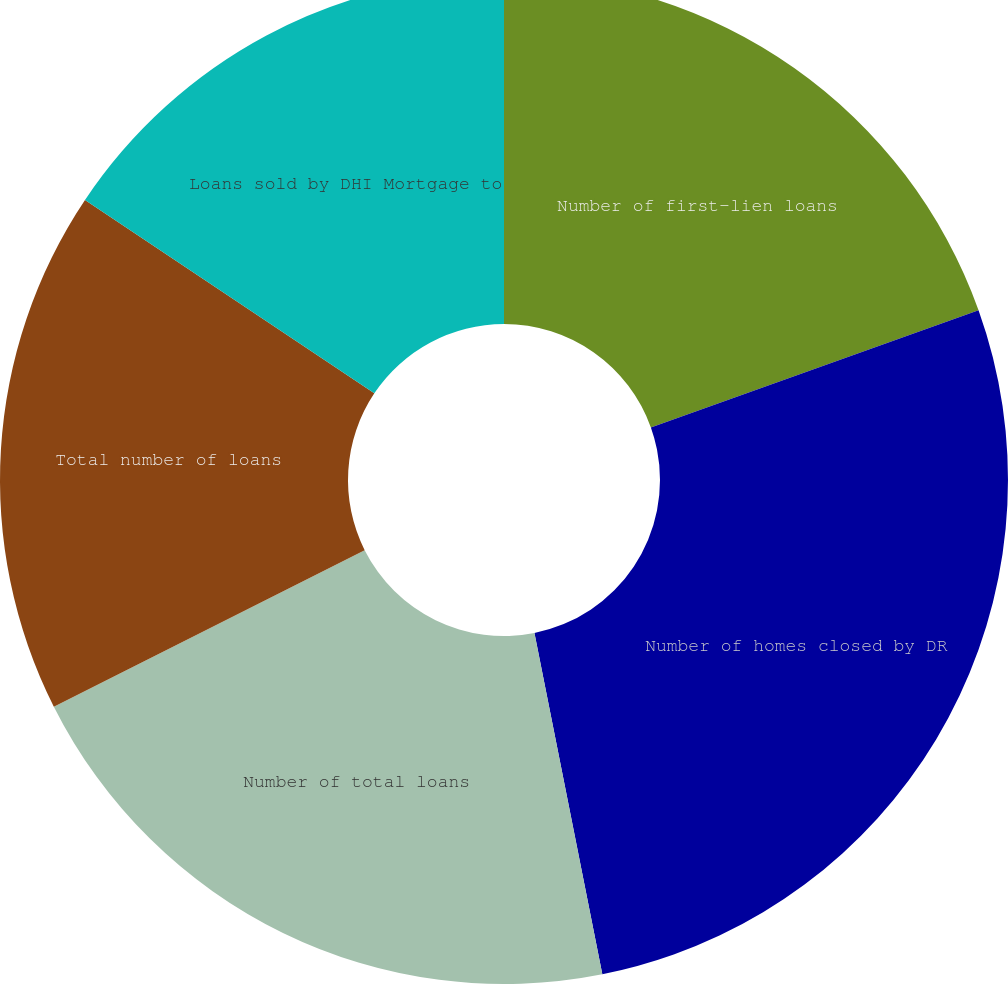Convert chart to OTSL. <chart><loc_0><loc_0><loc_500><loc_500><pie_chart><fcel>Number of first-lien loans<fcel>Number of homes closed by DR<fcel>Number of total loans<fcel>Total number of loans<fcel>Loans sold by DHI Mortgage to<nl><fcel>19.53%<fcel>27.34%<fcel>20.7%<fcel>16.8%<fcel>15.62%<nl></chart> 